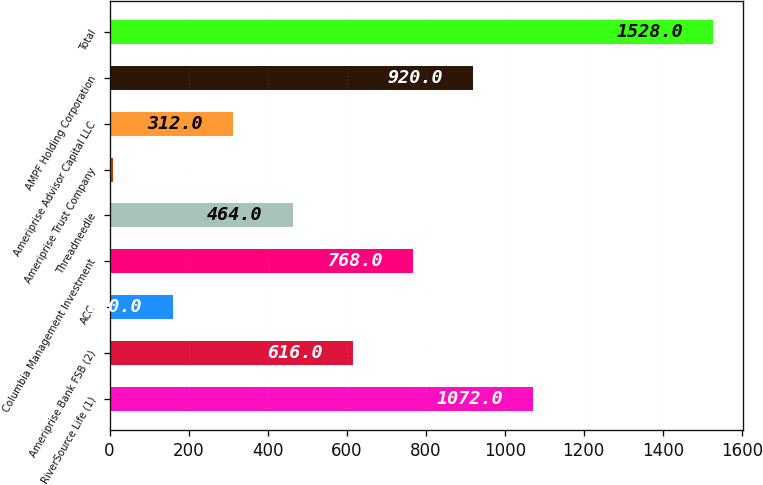<chart> <loc_0><loc_0><loc_500><loc_500><bar_chart><fcel>RiverSource Life (1)<fcel>Ameriprise Bank FSB (2)<fcel>ACC<fcel>Columbia Management Investment<fcel>Threadneedle<fcel>Ameriprise Trust Company<fcel>Ameriprise Advisor Capital LLC<fcel>AMPF Holding Corporation<fcel>Total<nl><fcel>1072<fcel>616<fcel>160<fcel>768<fcel>464<fcel>8<fcel>312<fcel>920<fcel>1528<nl></chart> 